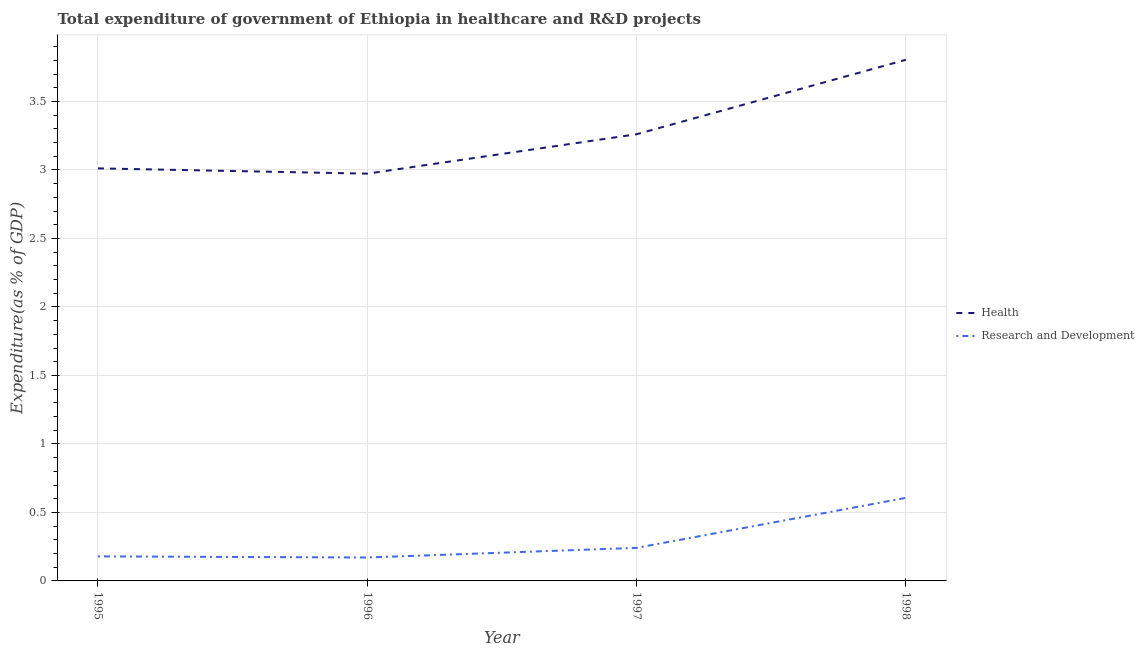What is the expenditure in healthcare in 1997?
Ensure brevity in your answer.  3.26. Across all years, what is the maximum expenditure in r&d?
Give a very brief answer. 0.61. Across all years, what is the minimum expenditure in r&d?
Offer a very short reply. 0.17. In which year was the expenditure in r&d maximum?
Make the answer very short. 1998. What is the total expenditure in r&d in the graph?
Make the answer very short. 1.2. What is the difference between the expenditure in r&d in 1996 and that in 1998?
Your response must be concise. -0.44. What is the difference between the expenditure in r&d in 1997 and the expenditure in healthcare in 1998?
Offer a very short reply. -3.56. What is the average expenditure in healthcare per year?
Keep it short and to the point. 3.26. In the year 1996, what is the difference between the expenditure in r&d and expenditure in healthcare?
Keep it short and to the point. -2.8. In how many years, is the expenditure in healthcare greater than 2.6 %?
Make the answer very short. 4. What is the ratio of the expenditure in r&d in 1995 to that in 1997?
Offer a very short reply. 0.74. Is the difference between the expenditure in healthcare in 1995 and 1997 greater than the difference between the expenditure in r&d in 1995 and 1997?
Make the answer very short. No. What is the difference between the highest and the second highest expenditure in r&d?
Give a very brief answer. 0.36. What is the difference between the highest and the lowest expenditure in healthcare?
Your answer should be very brief. 0.83. Is the sum of the expenditure in r&d in 1995 and 1997 greater than the maximum expenditure in healthcare across all years?
Your answer should be compact. No. Is the expenditure in healthcare strictly less than the expenditure in r&d over the years?
Ensure brevity in your answer.  No. How many years are there in the graph?
Make the answer very short. 4. What is the difference between two consecutive major ticks on the Y-axis?
Your answer should be very brief. 0.5. Does the graph contain any zero values?
Make the answer very short. No. Does the graph contain grids?
Provide a succinct answer. Yes. Where does the legend appear in the graph?
Keep it short and to the point. Center right. How many legend labels are there?
Offer a very short reply. 2. What is the title of the graph?
Your answer should be compact. Total expenditure of government of Ethiopia in healthcare and R&D projects. What is the label or title of the Y-axis?
Offer a terse response. Expenditure(as % of GDP). What is the Expenditure(as % of GDP) in Health in 1995?
Your answer should be compact. 3.01. What is the Expenditure(as % of GDP) in Research and Development in 1995?
Offer a terse response. 0.18. What is the Expenditure(as % of GDP) of Health in 1996?
Offer a terse response. 2.97. What is the Expenditure(as % of GDP) of Research and Development in 1996?
Your answer should be compact. 0.17. What is the Expenditure(as % of GDP) in Health in 1997?
Offer a terse response. 3.26. What is the Expenditure(as % of GDP) of Research and Development in 1997?
Your answer should be very brief. 0.24. What is the Expenditure(as % of GDP) of Health in 1998?
Your answer should be compact. 3.8. What is the Expenditure(as % of GDP) of Research and Development in 1998?
Your answer should be compact. 0.61. Across all years, what is the maximum Expenditure(as % of GDP) in Health?
Provide a short and direct response. 3.8. Across all years, what is the maximum Expenditure(as % of GDP) of Research and Development?
Provide a short and direct response. 0.61. Across all years, what is the minimum Expenditure(as % of GDP) in Health?
Offer a very short reply. 2.97. Across all years, what is the minimum Expenditure(as % of GDP) in Research and Development?
Make the answer very short. 0.17. What is the total Expenditure(as % of GDP) of Health in the graph?
Provide a short and direct response. 13.05. What is the total Expenditure(as % of GDP) in Research and Development in the graph?
Make the answer very short. 1.2. What is the difference between the Expenditure(as % of GDP) of Health in 1995 and that in 1996?
Offer a very short reply. 0.04. What is the difference between the Expenditure(as % of GDP) in Research and Development in 1995 and that in 1996?
Make the answer very short. 0.01. What is the difference between the Expenditure(as % of GDP) in Health in 1995 and that in 1997?
Your answer should be compact. -0.25. What is the difference between the Expenditure(as % of GDP) in Research and Development in 1995 and that in 1997?
Provide a short and direct response. -0.06. What is the difference between the Expenditure(as % of GDP) of Health in 1995 and that in 1998?
Your response must be concise. -0.79. What is the difference between the Expenditure(as % of GDP) in Research and Development in 1995 and that in 1998?
Make the answer very short. -0.43. What is the difference between the Expenditure(as % of GDP) of Health in 1996 and that in 1997?
Your answer should be very brief. -0.29. What is the difference between the Expenditure(as % of GDP) in Research and Development in 1996 and that in 1997?
Give a very brief answer. -0.07. What is the difference between the Expenditure(as % of GDP) of Health in 1996 and that in 1998?
Ensure brevity in your answer.  -0.83. What is the difference between the Expenditure(as % of GDP) of Research and Development in 1996 and that in 1998?
Offer a terse response. -0.44. What is the difference between the Expenditure(as % of GDP) in Health in 1997 and that in 1998?
Offer a terse response. -0.54. What is the difference between the Expenditure(as % of GDP) of Research and Development in 1997 and that in 1998?
Ensure brevity in your answer.  -0.36. What is the difference between the Expenditure(as % of GDP) in Health in 1995 and the Expenditure(as % of GDP) in Research and Development in 1996?
Keep it short and to the point. 2.84. What is the difference between the Expenditure(as % of GDP) of Health in 1995 and the Expenditure(as % of GDP) of Research and Development in 1997?
Your answer should be compact. 2.77. What is the difference between the Expenditure(as % of GDP) of Health in 1995 and the Expenditure(as % of GDP) of Research and Development in 1998?
Give a very brief answer. 2.41. What is the difference between the Expenditure(as % of GDP) in Health in 1996 and the Expenditure(as % of GDP) in Research and Development in 1997?
Ensure brevity in your answer.  2.73. What is the difference between the Expenditure(as % of GDP) in Health in 1996 and the Expenditure(as % of GDP) in Research and Development in 1998?
Offer a terse response. 2.37. What is the difference between the Expenditure(as % of GDP) in Health in 1997 and the Expenditure(as % of GDP) in Research and Development in 1998?
Make the answer very short. 2.65. What is the average Expenditure(as % of GDP) of Health per year?
Keep it short and to the point. 3.26. What is the average Expenditure(as % of GDP) of Research and Development per year?
Your response must be concise. 0.3. In the year 1995, what is the difference between the Expenditure(as % of GDP) in Health and Expenditure(as % of GDP) in Research and Development?
Give a very brief answer. 2.83. In the year 1996, what is the difference between the Expenditure(as % of GDP) of Health and Expenditure(as % of GDP) of Research and Development?
Make the answer very short. 2.8. In the year 1997, what is the difference between the Expenditure(as % of GDP) in Health and Expenditure(as % of GDP) in Research and Development?
Provide a succinct answer. 3.02. In the year 1998, what is the difference between the Expenditure(as % of GDP) of Health and Expenditure(as % of GDP) of Research and Development?
Provide a short and direct response. 3.2. What is the ratio of the Expenditure(as % of GDP) in Research and Development in 1995 to that in 1996?
Your answer should be compact. 1.05. What is the ratio of the Expenditure(as % of GDP) in Health in 1995 to that in 1997?
Your answer should be compact. 0.92. What is the ratio of the Expenditure(as % of GDP) in Research and Development in 1995 to that in 1997?
Ensure brevity in your answer.  0.74. What is the ratio of the Expenditure(as % of GDP) in Health in 1995 to that in 1998?
Keep it short and to the point. 0.79. What is the ratio of the Expenditure(as % of GDP) of Research and Development in 1995 to that in 1998?
Ensure brevity in your answer.  0.3. What is the ratio of the Expenditure(as % of GDP) in Health in 1996 to that in 1997?
Ensure brevity in your answer.  0.91. What is the ratio of the Expenditure(as % of GDP) of Research and Development in 1996 to that in 1997?
Provide a succinct answer. 0.71. What is the ratio of the Expenditure(as % of GDP) in Health in 1996 to that in 1998?
Provide a succinct answer. 0.78. What is the ratio of the Expenditure(as % of GDP) of Research and Development in 1996 to that in 1998?
Keep it short and to the point. 0.28. What is the ratio of the Expenditure(as % of GDP) of Research and Development in 1997 to that in 1998?
Your answer should be very brief. 0.4. What is the difference between the highest and the second highest Expenditure(as % of GDP) in Health?
Your answer should be compact. 0.54. What is the difference between the highest and the second highest Expenditure(as % of GDP) in Research and Development?
Your answer should be compact. 0.36. What is the difference between the highest and the lowest Expenditure(as % of GDP) of Health?
Offer a terse response. 0.83. What is the difference between the highest and the lowest Expenditure(as % of GDP) in Research and Development?
Ensure brevity in your answer.  0.44. 